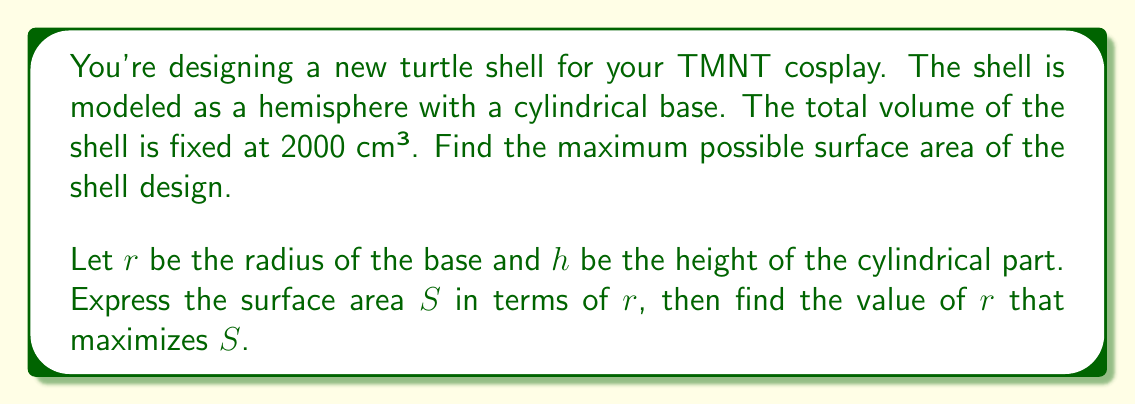Show me your answer to this math problem. 1) First, let's express the volume in terms of $r$ and $h$:
   $$V = \frac{2}{3}\pi r^3 + \pi r^2 h = 2000$$

2) Solve for $h$:
   $$h = \frac{2000}{\pi r^2} - \frac{2r}{3}$$

3) The surface area $S$ consists of the curved surface of the hemisphere and the lateral surface of the cylinder:
   $$S = 2\pi r^2 + 2\pi rh$$

4) Substitute $h$:
   $$S = 2\pi r^2 + 2\pi r(\frac{2000}{\pi r^2} - \frac{2r}{3})$$
   $$S = 2\pi r^2 + \frac{4000}{r} - \frac{4\pi r^2}{3}$$
   $$S = \frac{2\pi r^2}{3} + \frac{4000}{r}$$

5) To find the maximum, differentiate $S$ with respect to $r$ and set it to zero:
   $$\frac{dS}{dr} = \frac{4\pi r}{3} - \frac{4000}{r^2} = 0$$

6) Solve this equation:
   $$\frac{4\pi r}{3} = \frac{4000}{r^2}$$
   $$\frac{4\pi r^3}{3} = 4000$$
   $$r^3 = \frac{3000}{\pi}$$
   $$r = \sqrt[3]{\frac{3000}{\pi}} \approx 9.14 \text{ cm}$$

7) Verify that this is indeed a maximum by checking the second derivative is negative at this point.
Answer: $r = \sqrt[3]{\frac{3000}{\pi}} \approx 9.14 \text{ cm}$ 